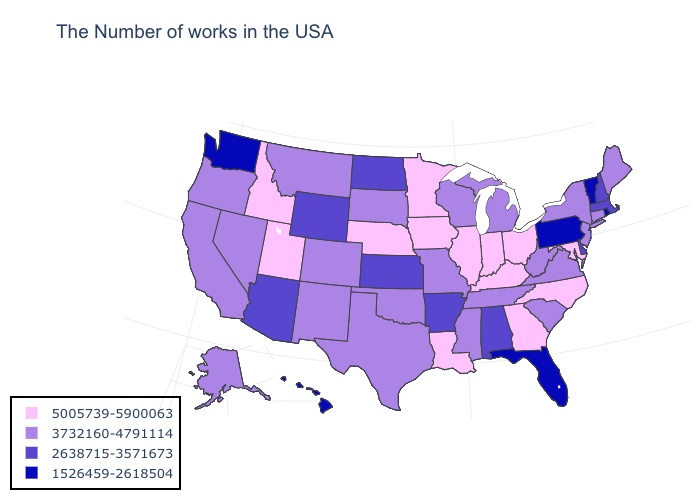Among the states that border New Hampshire , which have the highest value?
Answer briefly. Maine. What is the value of Massachusetts?
Write a very short answer. 2638715-3571673. What is the highest value in the South ?
Quick response, please. 5005739-5900063. Which states have the highest value in the USA?
Keep it brief. Maryland, North Carolina, Ohio, Georgia, Kentucky, Indiana, Illinois, Louisiana, Minnesota, Iowa, Nebraska, Utah, Idaho. What is the lowest value in the West?
Concise answer only. 1526459-2618504. Does Colorado have the highest value in the West?
Keep it brief. No. Name the states that have a value in the range 5005739-5900063?
Write a very short answer. Maryland, North Carolina, Ohio, Georgia, Kentucky, Indiana, Illinois, Louisiana, Minnesota, Iowa, Nebraska, Utah, Idaho. Which states have the highest value in the USA?
Quick response, please. Maryland, North Carolina, Ohio, Georgia, Kentucky, Indiana, Illinois, Louisiana, Minnesota, Iowa, Nebraska, Utah, Idaho. Which states have the highest value in the USA?
Give a very brief answer. Maryland, North Carolina, Ohio, Georgia, Kentucky, Indiana, Illinois, Louisiana, Minnesota, Iowa, Nebraska, Utah, Idaho. Name the states that have a value in the range 3732160-4791114?
Short answer required. Maine, Connecticut, New York, New Jersey, Virginia, South Carolina, West Virginia, Michigan, Tennessee, Wisconsin, Mississippi, Missouri, Oklahoma, Texas, South Dakota, Colorado, New Mexico, Montana, Nevada, California, Oregon, Alaska. Which states hav the highest value in the Northeast?
Answer briefly. Maine, Connecticut, New York, New Jersey. Does Pennsylvania have a lower value than Vermont?
Be succinct. No. Name the states that have a value in the range 1526459-2618504?
Be succinct. Rhode Island, Vermont, Pennsylvania, Florida, Washington, Hawaii. Among the states that border Tennessee , does Arkansas have the lowest value?
Be succinct. Yes. What is the highest value in states that border Illinois?
Write a very short answer. 5005739-5900063. 